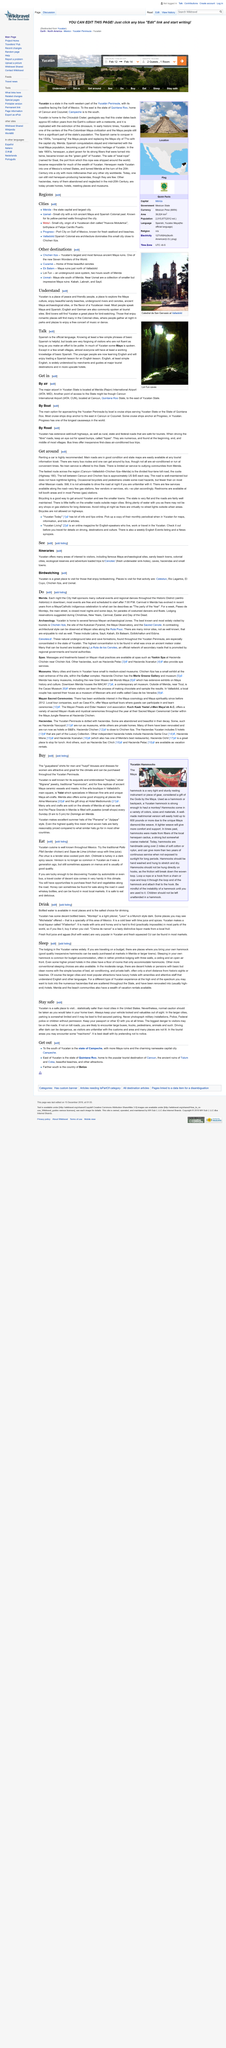List a handful of essential elements in this visual. If you want to talk to the locals in Yucatan, it is recommended that you use Spanish to communicate with them. The younger people are now learning to speak English. Yes, they are. The Maya language is also spoken in Yucatan, in addition to Spanish, which is the predominant language spoken in the region. 